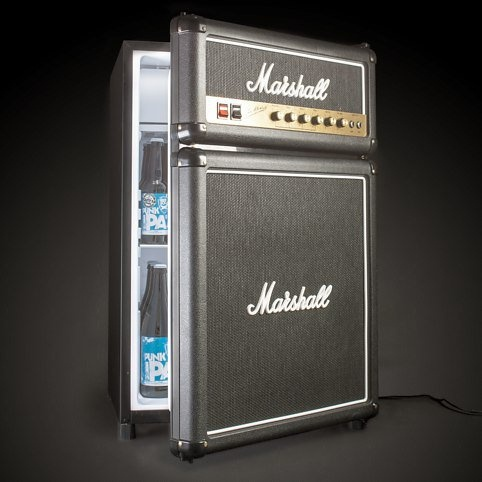Describe the objects in this image and their specific colors. I can see refrigerator in black, gray, lightgray, and darkgray tones, bottle in black, gray, lightgray, and teal tones, bottle in black, gray, lightgray, and darkgray tones, bottle in black and gray tones, and bottle in gray, lightgray, and black tones in this image. 